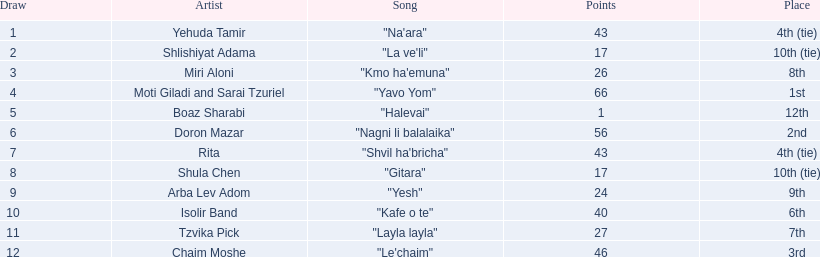In the competition, what are the point totals? 43, 17, 26, 66, 1, 56, 43, 17, 24, 40, 27, 46. What is the least amount of points? 1. Which artist was awarded these points? Boaz Sharabi. 